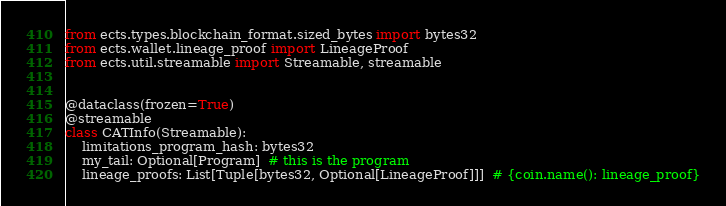Convert code to text. <code><loc_0><loc_0><loc_500><loc_500><_Python_>from ects.types.blockchain_format.sized_bytes import bytes32
from ects.wallet.lineage_proof import LineageProof
from ects.util.streamable import Streamable, streamable


@dataclass(frozen=True)
@streamable
class CATInfo(Streamable):
    limitations_program_hash: bytes32
    my_tail: Optional[Program]  # this is the program
    lineage_proofs: List[Tuple[bytes32, Optional[LineageProof]]]  # {coin.name(): lineage_proof}
</code> 